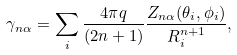<formula> <loc_0><loc_0><loc_500><loc_500>\gamma _ { n \alpha } = \sum _ { i } \frac { 4 \pi q } { ( 2 n + 1 ) } \frac { Z _ { n \alpha } ( \theta _ { i } , \phi _ { i } ) } { R _ { i } ^ { n + 1 } } ,</formula> 